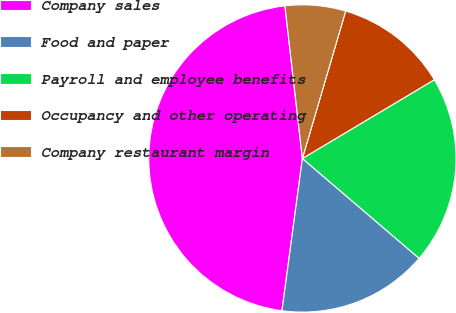<chart> <loc_0><loc_0><loc_500><loc_500><pie_chart><fcel>Company sales<fcel>Food and paper<fcel>Payroll and employee benefits<fcel>Occupancy and other operating<fcel>Company restaurant margin<nl><fcel>46.07%<fcel>15.86%<fcel>19.83%<fcel>11.89%<fcel>6.36%<nl></chart> 